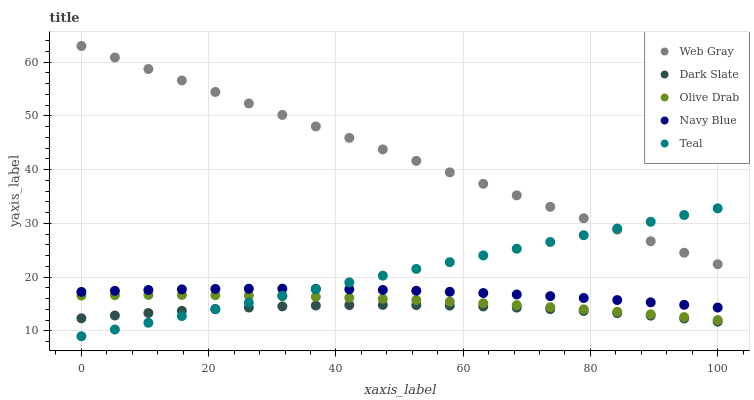Does Dark Slate have the minimum area under the curve?
Answer yes or no. Yes. Does Web Gray have the maximum area under the curve?
Answer yes or no. Yes. Does Teal have the minimum area under the curve?
Answer yes or no. No. Does Teal have the maximum area under the curve?
Answer yes or no. No. Is Teal the smoothest?
Answer yes or no. Yes. Is Dark Slate the roughest?
Answer yes or no. Yes. Is Web Gray the smoothest?
Answer yes or no. No. Is Web Gray the roughest?
Answer yes or no. No. Does Teal have the lowest value?
Answer yes or no. Yes. Does Web Gray have the lowest value?
Answer yes or no. No. Does Web Gray have the highest value?
Answer yes or no. Yes. Does Teal have the highest value?
Answer yes or no. No. Is Dark Slate less than Web Gray?
Answer yes or no. Yes. Is Navy Blue greater than Dark Slate?
Answer yes or no. Yes. Does Web Gray intersect Teal?
Answer yes or no. Yes. Is Web Gray less than Teal?
Answer yes or no. No. Is Web Gray greater than Teal?
Answer yes or no. No. Does Dark Slate intersect Web Gray?
Answer yes or no. No. 